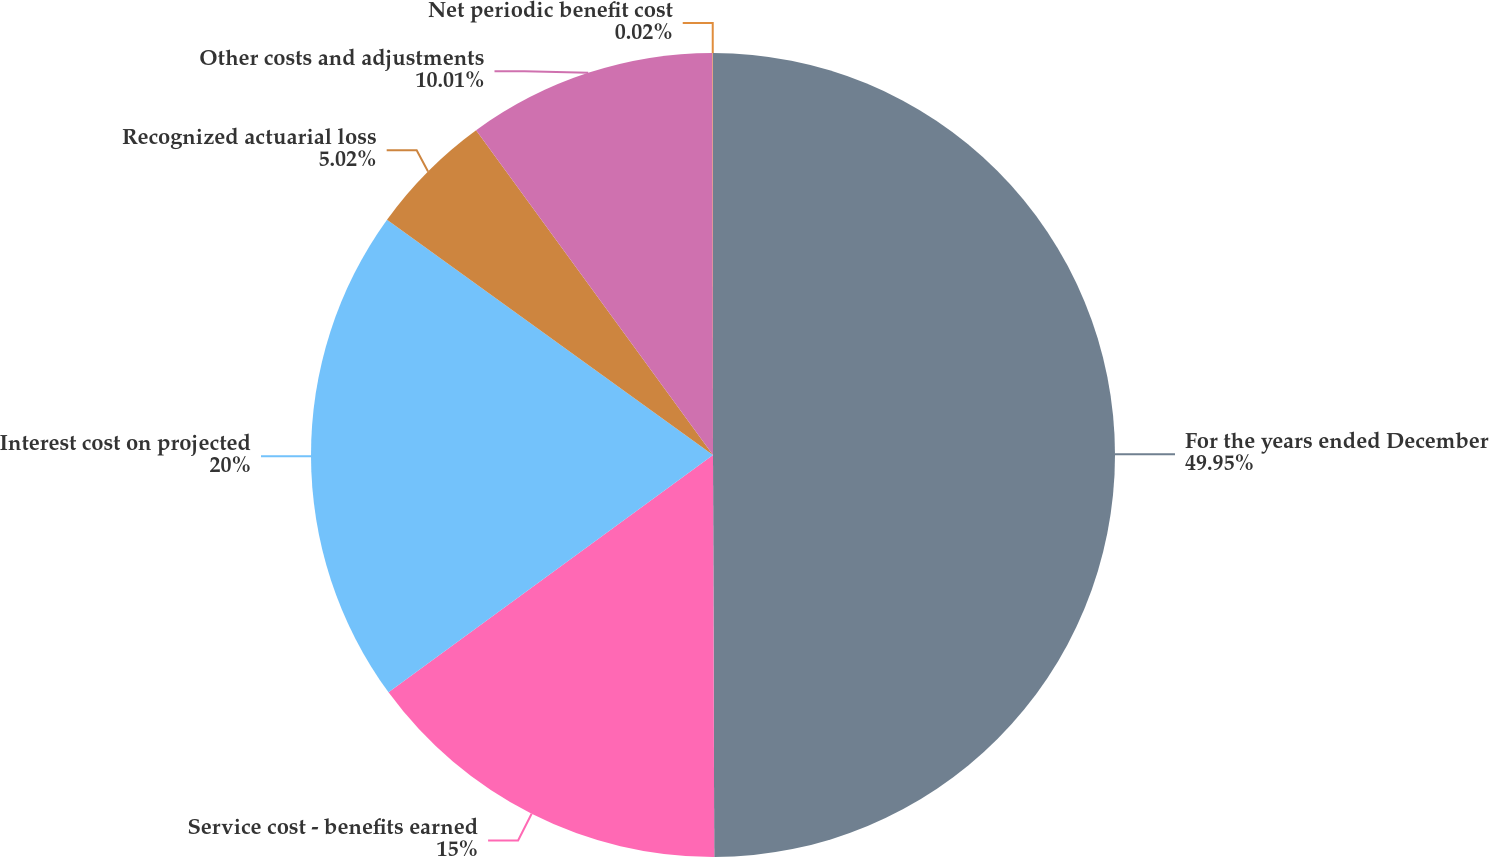Convert chart to OTSL. <chart><loc_0><loc_0><loc_500><loc_500><pie_chart><fcel>For the years ended December<fcel>Service cost - benefits earned<fcel>Interest cost on projected<fcel>Recognized actuarial loss<fcel>Other costs and adjustments<fcel>Net periodic benefit cost<nl><fcel>49.95%<fcel>15.0%<fcel>20.0%<fcel>5.02%<fcel>10.01%<fcel>0.02%<nl></chart> 